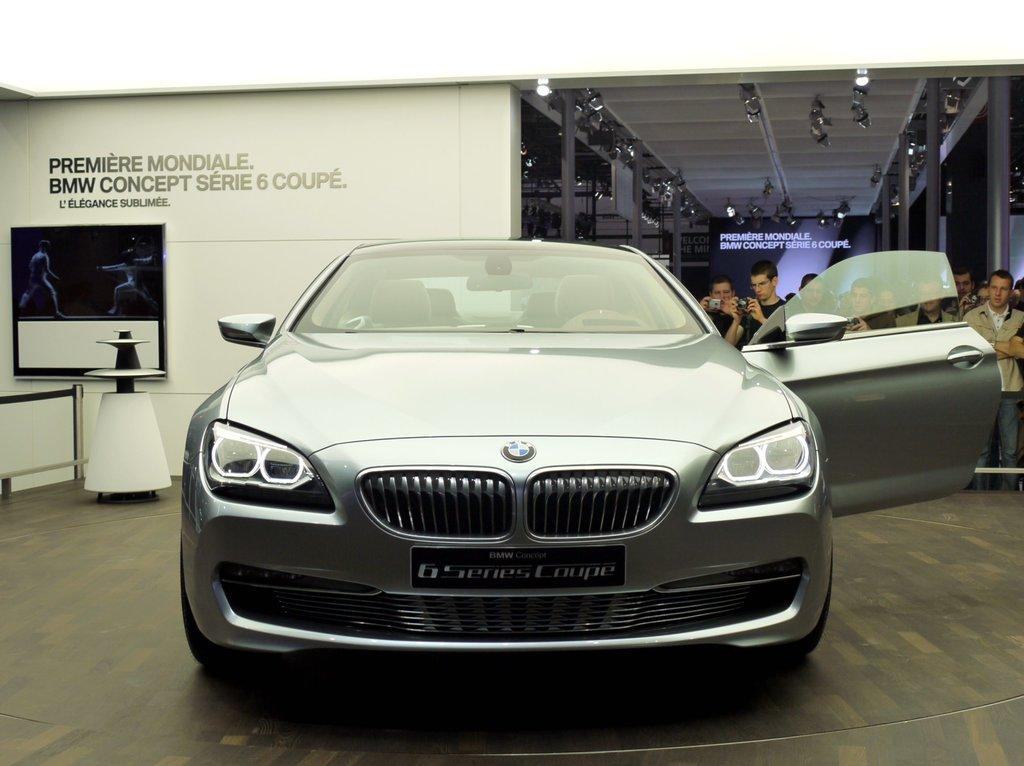What is the main subject in the image? There is a vehicle in the image. What can be seen in the background of the image? There are people, cameras, screens, a wall, and other objects visible in the background of the image. What is the surface that the vehicle and people are standing on? The floor is visible at the bottom of the image. Can you describe the garden in the image? There is no garden present in the image. What type of slip is the girl wearing in the image? There is no girl present in the image. 